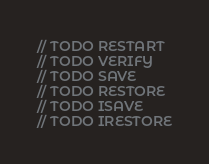Convert code to text. <code><loc_0><loc_0><loc_500><loc_500><_Scala_>// TODO RESTART
// TODO VERIFY
// TODO SAVE
// TODO RESTORE
// TODO ISAVE
// TODO IRESTORE</code> 